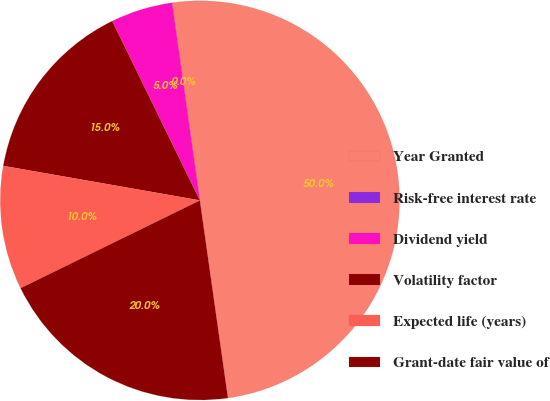<chart> <loc_0><loc_0><loc_500><loc_500><pie_chart><fcel>Year Granted<fcel>Risk-free interest rate<fcel>Dividend yield<fcel>Volatility factor<fcel>Expected life (years)<fcel>Grant-date fair value of<nl><fcel>49.97%<fcel>0.01%<fcel>5.01%<fcel>15.0%<fcel>10.01%<fcel>20.0%<nl></chart> 